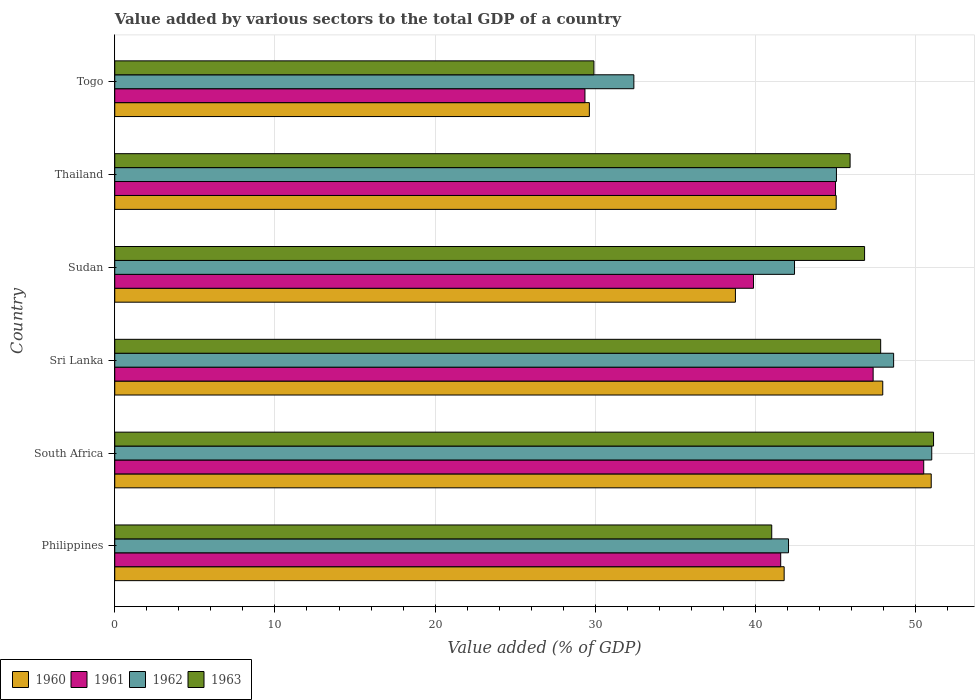How many different coloured bars are there?
Offer a terse response. 4. What is the label of the 4th group of bars from the top?
Your response must be concise. Sri Lanka. In how many cases, is the number of bars for a given country not equal to the number of legend labels?
Give a very brief answer. 0. What is the value added by various sectors to the total GDP in 1963 in Sri Lanka?
Your response must be concise. 47.82. Across all countries, what is the maximum value added by various sectors to the total GDP in 1963?
Give a very brief answer. 51.12. Across all countries, what is the minimum value added by various sectors to the total GDP in 1962?
Keep it short and to the point. 32.41. In which country was the value added by various sectors to the total GDP in 1960 maximum?
Your answer should be very brief. South Africa. In which country was the value added by various sectors to the total GDP in 1963 minimum?
Provide a succinct answer. Togo. What is the total value added by various sectors to the total GDP in 1960 in the graph?
Make the answer very short. 254.13. What is the difference between the value added by various sectors to the total GDP in 1961 in Philippines and that in Sudan?
Provide a succinct answer. 1.7. What is the difference between the value added by various sectors to the total GDP in 1960 in Sudan and the value added by various sectors to the total GDP in 1962 in Philippines?
Make the answer very short. -3.31. What is the average value added by various sectors to the total GDP in 1960 per country?
Keep it short and to the point. 42.35. What is the difference between the value added by various sectors to the total GDP in 1962 and value added by various sectors to the total GDP in 1961 in Thailand?
Keep it short and to the point. 0.06. What is the ratio of the value added by various sectors to the total GDP in 1962 in Sudan to that in Thailand?
Provide a succinct answer. 0.94. Is the difference between the value added by various sectors to the total GDP in 1962 in South Africa and Togo greater than the difference between the value added by various sectors to the total GDP in 1961 in South Africa and Togo?
Keep it short and to the point. No. What is the difference between the highest and the second highest value added by various sectors to the total GDP in 1960?
Keep it short and to the point. 3.03. What is the difference between the highest and the lowest value added by various sectors to the total GDP in 1963?
Provide a succinct answer. 21.2. What does the 1st bar from the top in Togo represents?
Offer a terse response. 1963. What does the 3rd bar from the bottom in Thailand represents?
Provide a succinct answer. 1962. Is it the case that in every country, the sum of the value added by various sectors to the total GDP in 1963 and value added by various sectors to the total GDP in 1961 is greater than the value added by various sectors to the total GDP in 1962?
Your answer should be compact. Yes. Are all the bars in the graph horizontal?
Your response must be concise. Yes. Are the values on the major ticks of X-axis written in scientific E-notation?
Make the answer very short. No. Does the graph contain any zero values?
Keep it short and to the point. No. Does the graph contain grids?
Provide a short and direct response. Yes. What is the title of the graph?
Ensure brevity in your answer.  Value added by various sectors to the total GDP of a country. What is the label or title of the X-axis?
Your answer should be very brief. Value added (% of GDP). What is the label or title of the Y-axis?
Make the answer very short. Country. What is the Value added (% of GDP) in 1960 in Philippines?
Offer a very short reply. 41.79. What is the Value added (% of GDP) of 1961 in Philippines?
Your answer should be compact. 41.57. What is the Value added (% of GDP) of 1962 in Philippines?
Your answer should be very brief. 42.06. What is the Value added (% of GDP) in 1963 in Philippines?
Offer a terse response. 41.01. What is the Value added (% of GDP) in 1960 in South Africa?
Your response must be concise. 50.97. What is the Value added (% of GDP) of 1961 in South Africa?
Provide a succinct answer. 50.5. What is the Value added (% of GDP) of 1962 in South Africa?
Make the answer very short. 51.01. What is the Value added (% of GDP) in 1963 in South Africa?
Offer a terse response. 51.12. What is the Value added (% of GDP) of 1960 in Sri Lanka?
Provide a succinct answer. 47.95. What is the Value added (% of GDP) of 1961 in Sri Lanka?
Provide a short and direct response. 47.35. What is the Value added (% of GDP) of 1962 in Sri Lanka?
Keep it short and to the point. 48.62. What is the Value added (% of GDP) of 1963 in Sri Lanka?
Your response must be concise. 47.82. What is the Value added (% of GDP) in 1960 in Sudan?
Provide a succinct answer. 38.75. What is the Value added (% of GDP) of 1961 in Sudan?
Make the answer very short. 39.88. What is the Value added (% of GDP) of 1962 in Sudan?
Keep it short and to the point. 42.44. What is the Value added (% of GDP) in 1963 in Sudan?
Ensure brevity in your answer.  46.81. What is the Value added (% of GDP) of 1960 in Thailand?
Your answer should be very brief. 45.04. What is the Value added (% of GDP) of 1961 in Thailand?
Your answer should be very brief. 45. What is the Value added (% of GDP) in 1962 in Thailand?
Provide a short and direct response. 45.05. What is the Value added (% of GDP) in 1963 in Thailand?
Keep it short and to the point. 45.91. What is the Value added (% of GDP) of 1960 in Togo?
Your response must be concise. 29.63. What is the Value added (% of GDP) in 1961 in Togo?
Offer a very short reply. 29.35. What is the Value added (% of GDP) of 1962 in Togo?
Offer a very short reply. 32.41. What is the Value added (% of GDP) in 1963 in Togo?
Provide a succinct answer. 29.91. Across all countries, what is the maximum Value added (% of GDP) of 1960?
Offer a terse response. 50.97. Across all countries, what is the maximum Value added (% of GDP) in 1961?
Your answer should be very brief. 50.5. Across all countries, what is the maximum Value added (% of GDP) in 1962?
Ensure brevity in your answer.  51.01. Across all countries, what is the maximum Value added (% of GDP) in 1963?
Your answer should be compact. 51.12. Across all countries, what is the minimum Value added (% of GDP) of 1960?
Offer a very short reply. 29.63. Across all countries, what is the minimum Value added (% of GDP) in 1961?
Ensure brevity in your answer.  29.35. Across all countries, what is the minimum Value added (% of GDP) of 1962?
Your answer should be very brief. 32.41. Across all countries, what is the minimum Value added (% of GDP) in 1963?
Provide a short and direct response. 29.91. What is the total Value added (% of GDP) in 1960 in the graph?
Provide a short and direct response. 254.13. What is the total Value added (% of GDP) of 1961 in the graph?
Offer a terse response. 253.65. What is the total Value added (% of GDP) of 1962 in the graph?
Provide a succinct answer. 261.59. What is the total Value added (% of GDP) of 1963 in the graph?
Ensure brevity in your answer.  262.58. What is the difference between the Value added (% of GDP) of 1960 in Philippines and that in South Africa?
Keep it short and to the point. -9.18. What is the difference between the Value added (% of GDP) in 1961 in Philippines and that in South Africa?
Offer a very short reply. -8.93. What is the difference between the Value added (% of GDP) of 1962 in Philippines and that in South Africa?
Your response must be concise. -8.94. What is the difference between the Value added (% of GDP) of 1963 in Philippines and that in South Africa?
Your answer should be compact. -10.1. What is the difference between the Value added (% of GDP) of 1960 in Philippines and that in Sri Lanka?
Provide a succinct answer. -6.15. What is the difference between the Value added (% of GDP) of 1961 in Philippines and that in Sri Lanka?
Your answer should be very brief. -5.77. What is the difference between the Value added (% of GDP) of 1962 in Philippines and that in Sri Lanka?
Offer a very short reply. -6.56. What is the difference between the Value added (% of GDP) of 1963 in Philippines and that in Sri Lanka?
Offer a terse response. -6.8. What is the difference between the Value added (% of GDP) in 1960 in Philippines and that in Sudan?
Provide a succinct answer. 3.04. What is the difference between the Value added (% of GDP) in 1961 in Philippines and that in Sudan?
Your answer should be compact. 1.7. What is the difference between the Value added (% of GDP) of 1962 in Philippines and that in Sudan?
Your answer should be very brief. -0.38. What is the difference between the Value added (% of GDP) of 1963 in Philippines and that in Sudan?
Your answer should be very brief. -5.8. What is the difference between the Value added (% of GDP) of 1960 in Philippines and that in Thailand?
Ensure brevity in your answer.  -3.25. What is the difference between the Value added (% of GDP) of 1961 in Philippines and that in Thailand?
Offer a terse response. -3.42. What is the difference between the Value added (% of GDP) in 1962 in Philippines and that in Thailand?
Your response must be concise. -2.99. What is the difference between the Value added (% of GDP) of 1963 in Philippines and that in Thailand?
Provide a succinct answer. -4.89. What is the difference between the Value added (% of GDP) of 1960 in Philippines and that in Togo?
Offer a terse response. 12.16. What is the difference between the Value added (% of GDP) of 1961 in Philippines and that in Togo?
Give a very brief answer. 12.22. What is the difference between the Value added (% of GDP) in 1962 in Philippines and that in Togo?
Your answer should be compact. 9.66. What is the difference between the Value added (% of GDP) in 1963 in Philippines and that in Togo?
Provide a succinct answer. 11.1. What is the difference between the Value added (% of GDP) of 1960 in South Africa and that in Sri Lanka?
Provide a succinct answer. 3.03. What is the difference between the Value added (% of GDP) of 1961 in South Africa and that in Sri Lanka?
Give a very brief answer. 3.16. What is the difference between the Value added (% of GDP) in 1962 in South Africa and that in Sri Lanka?
Your answer should be very brief. 2.38. What is the difference between the Value added (% of GDP) of 1963 in South Africa and that in Sri Lanka?
Your response must be concise. 3.3. What is the difference between the Value added (% of GDP) of 1960 in South Africa and that in Sudan?
Provide a short and direct response. 12.22. What is the difference between the Value added (% of GDP) of 1961 in South Africa and that in Sudan?
Your answer should be very brief. 10.63. What is the difference between the Value added (% of GDP) in 1962 in South Africa and that in Sudan?
Offer a terse response. 8.57. What is the difference between the Value added (% of GDP) of 1963 in South Africa and that in Sudan?
Your answer should be compact. 4.31. What is the difference between the Value added (% of GDP) in 1960 in South Africa and that in Thailand?
Offer a terse response. 5.93. What is the difference between the Value added (% of GDP) in 1961 in South Africa and that in Thailand?
Make the answer very short. 5.51. What is the difference between the Value added (% of GDP) of 1962 in South Africa and that in Thailand?
Offer a terse response. 5.95. What is the difference between the Value added (% of GDP) of 1963 in South Africa and that in Thailand?
Keep it short and to the point. 5.21. What is the difference between the Value added (% of GDP) of 1960 in South Africa and that in Togo?
Keep it short and to the point. 21.34. What is the difference between the Value added (% of GDP) in 1961 in South Africa and that in Togo?
Give a very brief answer. 21.15. What is the difference between the Value added (% of GDP) of 1962 in South Africa and that in Togo?
Offer a very short reply. 18.6. What is the difference between the Value added (% of GDP) in 1963 in South Africa and that in Togo?
Ensure brevity in your answer.  21.2. What is the difference between the Value added (% of GDP) of 1960 in Sri Lanka and that in Sudan?
Provide a succinct answer. 9.2. What is the difference between the Value added (% of GDP) in 1961 in Sri Lanka and that in Sudan?
Your answer should be very brief. 7.47. What is the difference between the Value added (% of GDP) in 1962 in Sri Lanka and that in Sudan?
Keep it short and to the point. 6.19. What is the difference between the Value added (% of GDP) in 1960 in Sri Lanka and that in Thailand?
Your answer should be very brief. 2.91. What is the difference between the Value added (% of GDP) of 1961 in Sri Lanka and that in Thailand?
Your response must be concise. 2.35. What is the difference between the Value added (% of GDP) of 1962 in Sri Lanka and that in Thailand?
Your answer should be very brief. 3.57. What is the difference between the Value added (% of GDP) in 1963 in Sri Lanka and that in Thailand?
Offer a terse response. 1.91. What is the difference between the Value added (% of GDP) in 1960 in Sri Lanka and that in Togo?
Give a very brief answer. 18.32. What is the difference between the Value added (% of GDP) in 1961 in Sri Lanka and that in Togo?
Ensure brevity in your answer.  17.99. What is the difference between the Value added (% of GDP) of 1962 in Sri Lanka and that in Togo?
Your answer should be compact. 16.22. What is the difference between the Value added (% of GDP) of 1963 in Sri Lanka and that in Togo?
Your response must be concise. 17.9. What is the difference between the Value added (% of GDP) of 1960 in Sudan and that in Thailand?
Offer a terse response. -6.29. What is the difference between the Value added (% of GDP) in 1961 in Sudan and that in Thailand?
Make the answer very short. -5.12. What is the difference between the Value added (% of GDP) of 1962 in Sudan and that in Thailand?
Give a very brief answer. -2.62. What is the difference between the Value added (% of GDP) of 1963 in Sudan and that in Thailand?
Make the answer very short. 0.9. What is the difference between the Value added (% of GDP) of 1960 in Sudan and that in Togo?
Your response must be concise. 9.12. What is the difference between the Value added (% of GDP) in 1961 in Sudan and that in Togo?
Keep it short and to the point. 10.52. What is the difference between the Value added (% of GDP) of 1962 in Sudan and that in Togo?
Your answer should be very brief. 10.03. What is the difference between the Value added (% of GDP) in 1963 in Sudan and that in Togo?
Make the answer very short. 16.9. What is the difference between the Value added (% of GDP) of 1960 in Thailand and that in Togo?
Ensure brevity in your answer.  15.41. What is the difference between the Value added (% of GDP) in 1961 in Thailand and that in Togo?
Make the answer very short. 15.64. What is the difference between the Value added (% of GDP) of 1962 in Thailand and that in Togo?
Provide a succinct answer. 12.65. What is the difference between the Value added (% of GDP) in 1963 in Thailand and that in Togo?
Give a very brief answer. 15.99. What is the difference between the Value added (% of GDP) in 1960 in Philippines and the Value added (% of GDP) in 1961 in South Africa?
Provide a short and direct response. -8.71. What is the difference between the Value added (% of GDP) in 1960 in Philippines and the Value added (% of GDP) in 1962 in South Africa?
Your answer should be very brief. -9.21. What is the difference between the Value added (% of GDP) in 1960 in Philippines and the Value added (% of GDP) in 1963 in South Africa?
Ensure brevity in your answer.  -9.33. What is the difference between the Value added (% of GDP) in 1961 in Philippines and the Value added (% of GDP) in 1962 in South Africa?
Give a very brief answer. -9.43. What is the difference between the Value added (% of GDP) of 1961 in Philippines and the Value added (% of GDP) of 1963 in South Africa?
Make the answer very short. -9.54. What is the difference between the Value added (% of GDP) in 1962 in Philippines and the Value added (% of GDP) in 1963 in South Africa?
Provide a short and direct response. -9.05. What is the difference between the Value added (% of GDP) of 1960 in Philippines and the Value added (% of GDP) of 1961 in Sri Lanka?
Your answer should be compact. -5.55. What is the difference between the Value added (% of GDP) of 1960 in Philippines and the Value added (% of GDP) of 1962 in Sri Lanka?
Your answer should be very brief. -6.83. What is the difference between the Value added (% of GDP) of 1960 in Philippines and the Value added (% of GDP) of 1963 in Sri Lanka?
Provide a short and direct response. -6.03. What is the difference between the Value added (% of GDP) in 1961 in Philippines and the Value added (% of GDP) in 1962 in Sri Lanka?
Make the answer very short. -7.05. What is the difference between the Value added (% of GDP) of 1961 in Philippines and the Value added (% of GDP) of 1963 in Sri Lanka?
Your answer should be compact. -6.24. What is the difference between the Value added (% of GDP) in 1962 in Philippines and the Value added (% of GDP) in 1963 in Sri Lanka?
Offer a terse response. -5.75. What is the difference between the Value added (% of GDP) of 1960 in Philippines and the Value added (% of GDP) of 1961 in Sudan?
Keep it short and to the point. 1.91. What is the difference between the Value added (% of GDP) in 1960 in Philippines and the Value added (% of GDP) in 1962 in Sudan?
Ensure brevity in your answer.  -0.65. What is the difference between the Value added (% of GDP) in 1960 in Philippines and the Value added (% of GDP) in 1963 in Sudan?
Your answer should be very brief. -5.02. What is the difference between the Value added (% of GDP) in 1961 in Philippines and the Value added (% of GDP) in 1962 in Sudan?
Keep it short and to the point. -0.86. What is the difference between the Value added (% of GDP) in 1961 in Philippines and the Value added (% of GDP) in 1963 in Sudan?
Your answer should be very brief. -5.24. What is the difference between the Value added (% of GDP) of 1962 in Philippines and the Value added (% of GDP) of 1963 in Sudan?
Make the answer very short. -4.75. What is the difference between the Value added (% of GDP) of 1960 in Philippines and the Value added (% of GDP) of 1961 in Thailand?
Your answer should be very brief. -3.21. What is the difference between the Value added (% of GDP) of 1960 in Philippines and the Value added (% of GDP) of 1962 in Thailand?
Make the answer very short. -3.26. What is the difference between the Value added (% of GDP) of 1960 in Philippines and the Value added (% of GDP) of 1963 in Thailand?
Provide a short and direct response. -4.12. What is the difference between the Value added (% of GDP) in 1961 in Philippines and the Value added (% of GDP) in 1962 in Thailand?
Offer a terse response. -3.48. What is the difference between the Value added (% of GDP) of 1961 in Philippines and the Value added (% of GDP) of 1963 in Thailand?
Ensure brevity in your answer.  -4.33. What is the difference between the Value added (% of GDP) in 1962 in Philippines and the Value added (% of GDP) in 1963 in Thailand?
Offer a terse response. -3.84. What is the difference between the Value added (% of GDP) of 1960 in Philippines and the Value added (% of GDP) of 1961 in Togo?
Offer a terse response. 12.44. What is the difference between the Value added (% of GDP) in 1960 in Philippines and the Value added (% of GDP) in 1962 in Togo?
Ensure brevity in your answer.  9.38. What is the difference between the Value added (% of GDP) in 1960 in Philippines and the Value added (% of GDP) in 1963 in Togo?
Give a very brief answer. 11.88. What is the difference between the Value added (% of GDP) of 1961 in Philippines and the Value added (% of GDP) of 1962 in Togo?
Offer a terse response. 9.17. What is the difference between the Value added (% of GDP) in 1961 in Philippines and the Value added (% of GDP) in 1963 in Togo?
Provide a short and direct response. 11.66. What is the difference between the Value added (% of GDP) in 1962 in Philippines and the Value added (% of GDP) in 1963 in Togo?
Keep it short and to the point. 12.15. What is the difference between the Value added (% of GDP) in 1960 in South Africa and the Value added (% of GDP) in 1961 in Sri Lanka?
Provide a succinct answer. 3.63. What is the difference between the Value added (% of GDP) in 1960 in South Africa and the Value added (% of GDP) in 1962 in Sri Lanka?
Keep it short and to the point. 2.35. What is the difference between the Value added (% of GDP) in 1960 in South Africa and the Value added (% of GDP) in 1963 in Sri Lanka?
Provide a succinct answer. 3.16. What is the difference between the Value added (% of GDP) of 1961 in South Africa and the Value added (% of GDP) of 1962 in Sri Lanka?
Provide a succinct answer. 1.88. What is the difference between the Value added (% of GDP) in 1961 in South Africa and the Value added (% of GDP) in 1963 in Sri Lanka?
Offer a very short reply. 2.69. What is the difference between the Value added (% of GDP) in 1962 in South Africa and the Value added (% of GDP) in 1963 in Sri Lanka?
Give a very brief answer. 3.19. What is the difference between the Value added (% of GDP) in 1960 in South Africa and the Value added (% of GDP) in 1961 in Sudan?
Keep it short and to the point. 11.09. What is the difference between the Value added (% of GDP) of 1960 in South Africa and the Value added (% of GDP) of 1962 in Sudan?
Keep it short and to the point. 8.53. What is the difference between the Value added (% of GDP) in 1960 in South Africa and the Value added (% of GDP) in 1963 in Sudan?
Your answer should be very brief. 4.16. What is the difference between the Value added (% of GDP) in 1961 in South Africa and the Value added (% of GDP) in 1962 in Sudan?
Offer a terse response. 8.07. What is the difference between the Value added (% of GDP) of 1961 in South Africa and the Value added (% of GDP) of 1963 in Sudan?
Offer a terse response. 3.69. What is the difference between the Value added (% of GDP) of 1962 in South Africa and the Value added (% of GDP) of 1963 in Sudan?
Offer a very short reply. 4.19. What is the difference between the Value added (% of GDP) of 1960 in South Africa and the Value added (% of GDP) of 1961 in Thailand?
Offer a terse response. 5.98. What is the difference between the Value added (% of GDP) in 1960 in South Africa and the Value added (% of GDP) in 1962 in Thailand?
Your answer should be compact. 5.92. What is the difference between the Value added (% of GDP) in 1960 in South Africa and the Value added (% of GDP) in 1963 in Thailand?
Your response must be concise. 5.06. What is the difference between the Value added (% of GDP) in 1961 in South Africa and the Value added (% of GDP) in 1962 in Thailand?
Give a very brief answer. 5.45. What is the difference between the Value added (% of GDP) of 1961 in South Africa and the Value added (% of GDP) of 1963 in Thailand?
Offer a terse response. 4.6. What is the difference between the Value added (% of GDP) of 1962 in South Africa and the Value added (% of GDP) of 1963 in Thailand?
Provide a short and direct response. 5.1. What is the difference between the Value added (% of GDP) in 1960 in South Africa and the Value added (% of GDP) in 1961 in Togo?
Your response must be concise. 21.62. What is the difference between the Value added (% of GDP) of 1960 in South Africa and the Value added (% of GDP) of 1962 in Togo?
Provide a succinct answer. 18.56. What is the difference between the Value added (% of GDP) in 1960 in South Africa and the Value added (% of GDP) in 1963 in Togo?
Make the answer very short. 21.06. What is the difference between the Value added (% of GDP) in 1961 in South Africa and the Value added (% of GDP) in 1962 in Togo?
Make the answer very short. 18.1. What is the difference between the Value added (% of GDP) in 1961 in South Africa and the Value added (% of GDP) in 1963 in Togo?
Your response must be concise. 20.59. What is the difference between the Value added (% of GDP) in 1962 in South Africa and the Value added (% of GDP) in 1963 in Togo?
Keep it short and to the point. 21.09. What is the difference between the Value added (% of GDP) of 1960 in Sri Lanka and the Value added (% of GDP) of 1961 in Sudan?
Make the answer very short. 8.07. What is the difference between the Value added (% of GDP) in 1960 in Sri Lanka and the Value added (% of GDP) in 1962 in Sudan?
Ensure brevity in your answer.  5.51. What is the difference between the Value added (% of GDP) in 1960 in Sri Lanka and the Value added (% of GDP) in 1963 in Sudan?
Your answer should be very brief. 1.14. What is the difference between the Value added (% of GDP) in 1961 in Sri Lanka and the Value added (% of GDP) in 1962 in Sudan?
Your answer should be compact. 4.91. What is the difference between the Value added (% of GDP) of 1961 in Sri Lanka and the Value added (% of GDP) of 1963 in Sudan?
Offer a terse response. 0.53. What is the difference between the Value added (% of GDP) in 1962 in Sri Lanka and the Value added (% of GDP) in 1963 in Sudan?
Provide a short and direct response. 1.81. What is the difference between the Value added (% of GDP) in 1960 in Sri Lanka and the Value added (% of GDP) in 1961 in Thailand?
Your answer should be compact. 2.95. What is the difference between the Value added (% of GDP) in 1960 in Sri Lanka and the Value added (% of GDP) in 1962 in Thailand?
Keep it short and to the point. 2.89. What is the difference between the Value added (% of GDP) of 1960 in Sri Lanka and the Value added (% of GDP) of 1963 in Thailand?
Give a very brief answer. 2.04. What is the difference between the Value added (% of GDP) in 1961 in Sri Lanka and the Value added (% of GDP) in 1962 in Thailand?
Keep it short and to the point. 2.29. What is the difference between the Value added (% of GDP) of 1961 in Sri Lanka and the Value added (% of GDP) of 1963 in Thailand?
Give a very brief answer. 1.44. What is the difference between the Value added (% of GDP) in 1962 in Sri Lanka and the Value added (% of GDP) in 1963 in Thailand?
Keep it short and to the point. 2.72. What is the difference between the Value added (% of GDP) in 1960 in Sri Lanka and the Value added (% of GDP) in 1961 in Togo?
Ensure brevity in your answer.  18.59. What is the difference between the Value added (% of GDP) in 1960 in Sri Lanka and the Value added (% of GDP) in 1962 in Togo?
Provide a succinct answer. 15.54. What is the difference between the Value added (% of GDP) of 1960 in Sri Lanka and the Value added (% of GDP) of 1963 in Togo?
Offer a very short reply. 18.03. What is the difference between the Value added (% of GDP) of 1961 in Sri Lanka and the Value added (% of GDP) of 1962 in Togo?
Your response must be concise. 14.94. What is the difference between the Value added (% of GDP) in 1961 in Sri Lanka and the Value added (% of GDP) in 1963 in Togo?
Provide a short and direct response. 17.43. What is the difference between the Value added (% of GDP) in 1962 in Sri Lanka and the Value added (% of GDP) in 1963 in Togo?
Give a very brief answer. 18.71. What is the difference between the Value added (% of GDP) in 1960 in Sudan and the Value added (% of GDP) in 1961 in Thailand?
Give a very brief answer. -6.25. What is the difference between the Value added (% of GDP) of 1960 in Sudan and the Value added (% of GDP) of 1962 in Thailand?
Make the answer very short. -6.31. What is the difference between the Value added (% of GDP) in 1960 in Sudan and the Value added (% of GDP) in 1963 in Thailand?
Offer a very short reply. -7.16. What is the difference between the Value added (% of GDP) in 1961 in Sudan and the Value added (% of GDP) in 1962 in Thailand?
Provide a succinct answer. -5.18. What is the difference between the Value added (% of GDP) in 1961 in Sudan and the Value added (% of GDP) in 1963 in Thailand?
Give a very brief answer. -6.03. What is the difference between the Value added (% of GDP) of 1962 in Sudan and the Value added (% of GDP) of 1963 in Thailand?
Ensure brevity in your answer.  -3.47. What is the difference between the Value added (% of GDP) of 1960 in Sudan and the Value added (% of GDP) of 1961 in Togo?
Provide a succinct answer. 9.39. What is the difference between the Value added (% of GDP) in 1960 in Sudan and the Value added (% of GDP) in 1962 in Togo?
Provide a succinct answer. 6.34. What is the difference between the Value added (% of GDP) in 1960 in Sudan and the Value added (% of GDP) in 1963 in Togo?
Your answer should be compact. 8.83. What is the difference between the Value added (% of GDP) of 1961 in Sudan and the Value added (% of GDP) of 1962 in Togo?
Provide a short and direct response. 7.47. What is the difference between the Value added (% of GDP) of 1961 in Sudan and the Value added (% of GDP) of 1963 in Togo?
Make the answer very short. 9.96. What is the difference between the Value added (% of GDP) of 1962 in Sudan and the Value added (% of GDP) of 1963 in Togo?
Your answer should be compact. 12.52. What is the difference between the Value added (% of GDP) in 1960 in Thailand and the Value added (% of GDP) in 1961 in Togo?
Provide a short and direct response. 15.68. What is the difference between the Value added (% of GDP) of 1960 in Thailand and the Value added (% of GDP) of 1962 in Togo?
Ensure brevity in your answer.  12.63. What is the difference between the Value added (% of GDP) of 1960 in Thailand and the Value added (% of GDP) of 1963 in Togo?
Keep it short and to the point. 15.12. What is the difference between the Value added (% of GDP) in 1961 in Thailand and the Value added (% of GDP) in 1962 in Togo?
Offer a terse response. 12.59. What is the difference between the Value added (% of GDP) in 1961 in Thailand and the Value added (% of GDP) in 1963 in Togo?
Make the answer very short. 15.08. What is the difference between the Value added (% of GDP) in 1962 in Thailand and the Value added (% of GDP) in 1963 in Togo?
Provide a succinct answer. 15.14. What is the average Value added (% of GDP) in 1960 per country?
Provide a short and direct response. 42.35. What is the average Value added (% of GDP) in 1961 per country?
Offer a very short reply. 42.28. What is the average Value added (% of GDP) of 1962 per country?
Your answer should be compact. 43.6. What is the average Value added (% of GDP) of 1963 per country?
Your answer should be compact. 43.76. What is the difference between the Value added (% of GDP) in 1960 and Value added (% of GDP) in 1961 in Philippines?
Offer a very short reply. 0.22. What is the difference between the Value added (% of GDP) of 1960 and Value added (% of GDP) of 1962 in Philippines?
Your answer should be very brief. -0.27. What is the difference between the Value added (% of GDP) of 1960 and Value added (% of GDP) of 1963 in Philippines?
Your response must be concise. 0.78. What is the difference between the Value added (% of GDP) in 1961 and Value added (% of GDP) in 1962 in Philippines?
Provide a succinct answer. -0.49. What is the difference between the Value added (% of GDP) of 1961 and Value added (% of GDP) of 1963 in Philippines?
Ensure brevity in your answer.  0.56. What is the difference between the Value added (% of GDP) of 1962 and Value added (% of GDP) of 1963 in Philippines?
Your answer should be very brief. 1.05. What is the difference between the Value added (% of GDP) of 1960 and Value added (% of GDP) of 1961 in South Africa?
Offer a terse response. 0.47. What is the difference between the Value added (% of GDP) of 1960 and Value added (% of GDP) of 1962 in South Africa?
Give a very brief answer. -0.03. What is the difference between the Value added (% of GDP) of 1960 and Value added (% of GDP) of 1963 in South Africa?
Offer a very short reply. -0.15. What is the difference between the Value added (% of GDP) of 1961 and Value added (% of GDP) of 1962 in South Africa?
Ensure brevity in your answer.  -0.5. What is the difference between the Value added (% of GDP) in 1961 and Value added (% of GDP) in 1963 in South Africa?
Offer a terse response. -0.61. What is the difference between the Value added (% of GDP) of 1962 and Value added (% of GDP) of 1963 in South Africa?
Offer a very short reply. -0.11. What is the difference between the Value added (% of GDP) of 1960 and Value added (% of GDP) of 1961 in Sri Lanka?
Ensure brevity in your answer.  0.6. What is the difference between the Value added (% of GDP) of 1960 and Value added (% of GDP) of 1962 in Sri Lanka?
Your answer should be very brief. -0.68. What is the difference between the Value added (% of GDP) in 1960 and Value added (% of GDP) in 1963 in Sri Lanka?
Your response must be concise. 0.13. What is the difference between the Value added (% of GDP) of 1961 and Value added (% of GDP) of 1962 in Sri Lanka?
Give a very brief answer. -1.28. What is the difference between the Value added (% of GDP) in 1961 and Value added (% of GDP) in 1963 in Sri Lanka?
Give a very brief answer. -0.47. What is the difference between the Value added (% of GDP) in 1962 and Value added (% of GDP) in 1963 in Sri Lanka?
Provide a succinct answer. 0.81. What is the difference between the Value added (% of GDP) in 1960 and Value added (% of GDP) in 1961 in Sudan?
Your answer should be very brief. -1.13. What is the difference between the Value added (% of GDP) in 1960 and Value added (% of GDP) in 1962 in Sudan?
Make the answer very short. -3.69. What is the difference between the Value added (% of GDP) in 1960 and Value added (% of GDP) in 1963 in Sudan?
Provide a short and direct response. -8.06. What is the difference between the Value added (% of GDP) of 1961 and Value added (% of GDP) of 1962 in Sudan?
Give a very brief answer. -2.56. What is the difference between the Value added (% of GDP) of 1961 and Value added (% of GDP) of 1963 in Sudan?
Your answer should be very brief. -6.93. What is the difference between the Value added (% of GDP) of 1962 and Value added (% of GDP) of 1963 in Sudan?
Your answer should be very brief. -4.37. What is the difference between the Value added (% of GDP) in 1960 and Value added (% of GDP) in 1961 in Thailand?
Provide a short and direct response. 0.04. What is the difference between the Value added (% of GDP) in 1960 and Value added (% of GDP) in 1962 in Thailand?
Your answer should be compact. -0.02. What is the difference between the Value added (% of GDP) of 1960 and Value added (% of GDP) of 1963 in Thailand?
Your answer should be compact. -0.87. What is the difference between the Value added (% of GDP) in 1961 and Value added (% of GDP) in 1962 in Thailand?
Make the answer very short. -0.06. What is the difference between the Value added (% of GDP) of 1961 and Value added (% of GDP) of 1963 in Thailand?
Your answer should be compact. -0.91. What is the difference between the Value added (% of GDP) of 1962 and Value added (% of GDP) of 1963 in Thailand?
Give a very brief answer. -0.85. What is the difference between the Value added (% of GDP) of 1960 and Value added (% of GDP) of 1961 in Togo?
Your answer should be compact. 0.27. What is the difference between the Value added (% of GDP) in 1960 and Value added (% of GDP) in 1962 in Togo?
Provide a short and direct response. -2.78. What is the difference between the Value added (% of GDP) of 1960 and Value added (% of GDP) of 1963 in Togo?
Keep it short and to the point. -0.28. What is the difference between the Value added (% of GDP) of 1961 and Value added (% of GDP) of 1962 in Togo?
Make the answer very short. -3.05. What is the difference between the Value added (% of GDP) in 1961 and Value added (% of GDP) in 1963 in Togo?
Provide a succinct answer. -0.56. What is the difference between the Value added (% of GDP) in 1962 and Value added (% of GDP) in 1963 in Togo?
Ensure brevity in your answer.  2.49. What is the ratio of the Value added (% of GDP) in 1960 in Philippines to that in South Africa?
Ensure brevity in your answer.  0.82. What is the ratio of the Value added (% of GDP) of 1961 in Philippines to that in South Africa?
Ensure brevity in your answer.  0.82. What is the ratio of the Value added (% of GDP) of 1962 in Philippines to that in South Africa?
Offer a terse response. 0.82. What is the ratio of the Value added (% of GDP) of 1963 in Philippines to that in South Africa?
Keep it short and to the point. 0.8. What is the ratio of the Value added (% of GDP) of 1960 in Philippines to that in Sri Lanka?
Your response must be concise. 0.87. What is the ratio of the Value added (% of GDP) in 1961 in Philippines to that in Sri Lanka?
Provide a short and direct response. 0.88. What is the ratio of the Value added (% of GDP) in 1962 in Philippines to that in Sri Lanka?
Provide a succinct answer. 0.87. What is the ratio of the Value added (% of GDP) in 1963 in Philippines to that in Sri Lanka?
Ensure brevity in your answer.  0.86. What is the ratio of the Value added (% of GDP) of 1960 in Philippines to that in Sudan?
Your answer should be very brief. 1.08. What is the ratio of the Value added (% of GDP) of 1961 in Philippines to that in Sudan?
Give a very brief answer. 1.04. What is the ratio of the Value added (% of GDP) of 1963 in Philippines to that in Sudan?
Give a very brief answer. 0.88. What is the ratio of the Value added (% of GDP) of 1960 in Philippines to that in Thailand?
Ensure brevity in your answer.  0.93. What is the ratio of the Value added (% of GDP) in 1961 in Philippines to that in Thailand?
Your response must be concise. 0.92. What is the ratio of the Value added (% of GDP) in 1962 in Philippines to that in Thailand?
Ensure brevity in your answer.  0.93. What is the ratio of the Value added (% of GDP) of 1963 in Philippines to that in Thailand?
Ensure brevity in your answer.  0.89. What is the ratio of the Value added (% of GDP) in 1960 in Philippines to that in Togo?
Give a very brief answer. 1.41. What is the ratio of the Value added (% of GDP) in 1961 in Philippines to that in Togo?
Keep it short and to the point. 1.42. What is the ratio of the Value added (% of GDP) in 1962 in Philippines to that in Togo?
Ensure brevity in your answer.  1.3. What is the ratio of the Value added (% of GDP) of 1963 in Philippines to that in Togo?
Offer a very short reply. 1.37. What is the ratio of the Value added (% of GDP) in 1960 in South Africa to that in Sri Lanka?
Ensure brevity in your answer.  1.06. What is the ratio of the Value added (% of GDP) in 1961 in South Africa to that in Sri Lanka?
Offer a terse response. 1.07. What is the ratio of the Value added (% of GDP) of 1962 in South Africa to that in Sri Lanka?
Your response must be concise. 1.05. What is the ratio of the Value added (% of GDP) of 1963 in South Africa to that in Sri Lanka?
Make the answer very short. 1.07. What is the ratio of the Value added (% of GDP) in 1960 in South Africa to that in Sudan?
Your answer should be very brief. 1.32. What is the ratio of the Value added (% of GDP) of 1961 in South Africa to that in Sudan?
Ensure brevity in your answer.  1.27. What is the ratio of the Value added (% of GDP) of 1962 in South Africa to that in Sudan?
Offer a very short reply. 1.2. What is the ratio of the Value added (% of GDP) of 1963 in South Africa to that in Sudan?
Offer a terse response. 1.09. What is the ratio of the Value added (% of GDP) of 1960 in South Africa to that in Thailand?
Your answer should be compact. 1.13. What is the ratio of the Value added (% of GDP) in 1961 in South Africa to that in Thailand?
Give a very brief answer. 1.12. What is the ratio of the Value added (% of GDP) in 1962 in South Africa to that in Thailand?
Provide a succinct answer. 1.13. What is the ratio of the Value added (% of GDP) in 1963 in South Africa to that in Thailand?
Provide a short and direct response. 1.11. What is the ratio of the Value added (% of GDP) of 1960 in South Africa to that in Togo?
Provide a succinct answer. 1.72. What is the ratio of the Value added (% of GDP) in 1961 in South Africa to that in Togo?
Provide a succinct answer. 1.72. What is the ratio of the Value added (% of GDP) of 1962 in South Africa to that in Togo?
Your answer should be very brief. 1.57. What is the ratio of the Value added (% of GDP) in 1963 in South Africa to that in Togo?
Give a very brief answer. 1.71. What is the ratio of the Value added (% of GDP) in 1960 in Sri Lanka to that in Sudan?
Make the answer very short. 1.24. What is the ratio of the Value added (% of GDP) in 1961 in Sri Lanka to that in Sudan?
Provide a short and direct response. 1.19. What is the ratio of the Value added (% of GDP) in 1962 in Sri Lanka to that in Sudan?
Give a very brief answer. 1.15. What is the ratio of the Value added (% of GDP) in 1963 in Sri Lanka to that in Sudan?
Make the answer very short. 1.02. What is the ratio of the Value added (% of GDP) in 1960 in Sri Lanka to that in Thailand?
Keep it short and to the point. 1.06. What is the ratio of the Value added (% of GDP) of 1961 in Sri Lanka to that in Thailand?
Provide a succinct answer. 1.05. What is the ratio of the Value added (% of GDP) of 1962 in Sri Lanka to that in Thailand?
Your answer should be very brief. 1.08. What is the ratio of the Value added (% of GDP) of 1963 in Sri Lanka to that in Thailand?
Ensure brevity in your answer.  1.04. What is the ratio of the Value added (% of GDP) of 1960 in Sri Lanka to that in Togo?
Your response must be concise. 1.62. What is the ratio of the Value added (% of GDP) of 1961 in Sri Lanka to that in Togo?
Provide a succinct answer. 1.61. What is the ratio of the Value added (% of GDP) of 1962 in Sri Lanka to that in Togo?
Your answer should be very brief. 1.5. What is the ratio of the Value added (% of GDP) in 1963 in Sri Lanka to that in Togo?
Keep it short and to the point. 1.6. What is the ratio of the Value added (% of GDP) of 1960 in Sudan to that in Thailand?
Your response must be concise. 0.86. What is the ratio of the Value added (% of GDP) of 1961 in Sudan to that in Thailand?
Your response must be concise. 0.89. What is the ratio of the Value added (% of GDP) of 1962 in Sudan to that in Thailand?
Your answer should be compact. 0.94. What is the ratio of the Value added (% of GDP) of 1963 in Sudan to that in Thailand?
Give a very brief answer. 1.02. What is the ratio of the Value added (% of GDP) in 1960 in Sudan to that in Togo?
Your answer should be very brief. 1.31. What is the ratio of the Value added (% of GDP) in 1961 in Sudan to that in Togo?
Provide a succinct answer. 1.36. What is the ratio of the Value added (% of GDP) of 1962 in Sudan to that in Togo?
Provide a short and direct response. 1.31. What is the ratio of the Value added (% of GDP) in 1963 in Sudan to that in Togo?
Make the answer very short. 1.56. What is the ratio of the Value added (% of GDP) of 1960 in Thailand to that in Togo?
Your response must be concise. 1.52. What is the ratio of the Value added (% of GDP) in 1961 in Thailand to that in Togo?
Keep it short and to the point. 1.53. What is the ratio of the Value added (% of GDP) of 1962 in Thailand to that in Togo?
Ensure brevity in your answer.  1.39. What is the ratio of the Value added (% of GDP) in 1963 in Thailand to that in Togo?
Offer a terse response. 1.53. What is the difference between the highest and the second highest Value added (% of GDP) of 1960?
Provide a short and direct response. 3.03. What is the difference between the highest and the second highest Value added (% of GDP) in 1961?
Keep it short and to the point. 3.16. What is the difference between the highest and the second highest Value added (% of GDP) of 1962?
Offer a very short reply. 2.38. What is the difference between the highest and the second highest Value added (% of GDP) in 1963?
Give a very brief answer. 3.3. What is the difference between the highest and the lowest Value added (% of GDP) of 1960?
Keep it short and to the point. 21.34. What is the difference between the highest and the lowest Value added (% of GDP) of 1961?
Give a very brief answer. 21.15. What is the difference between the highest and the lowest Value added (% of GDP) of 1962?
Give a very brief answer. 18.6. What is the difference between the highest and the lowest Value added (% of GDP) of 1963?
Offer a terse response. 21.2. 